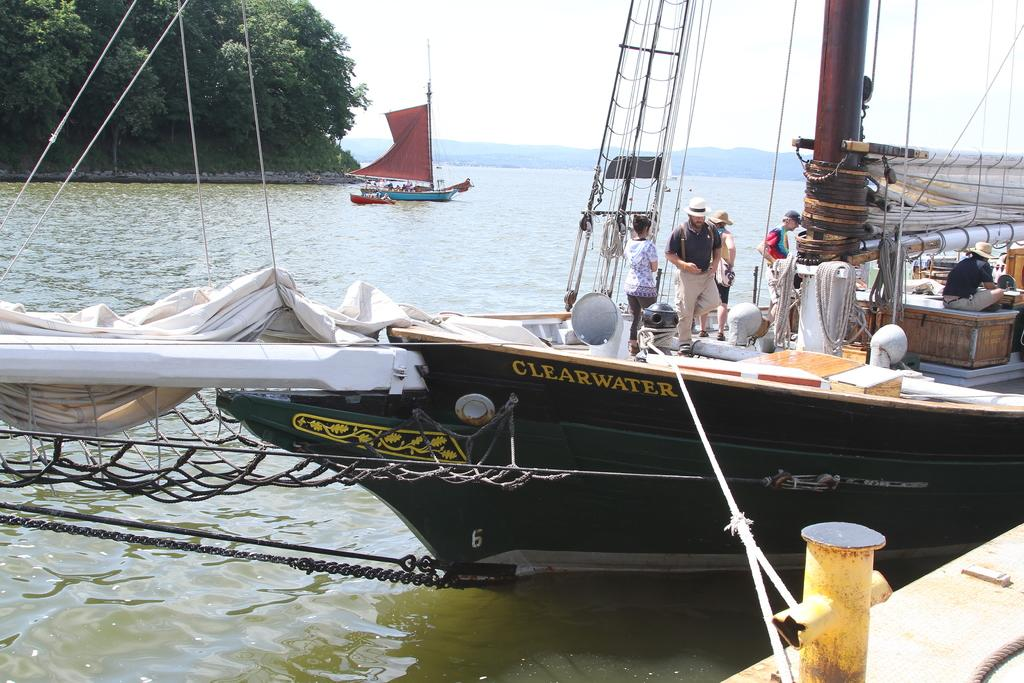What is happening in the image involving water? There are boats on water in the image. Can you describe the people visible in the image? There are people visible in the image. What type of natural environment is depicted in the background? There are trees, mountains, and the sky visible in the background of the image. What type of skin condition can be seen on the people in the image? There is no indication of any skin condition on the people in the image. Where is the bedroom located in the image? There is no bedroom present in the image; it features boats on water with people and a natural background. 